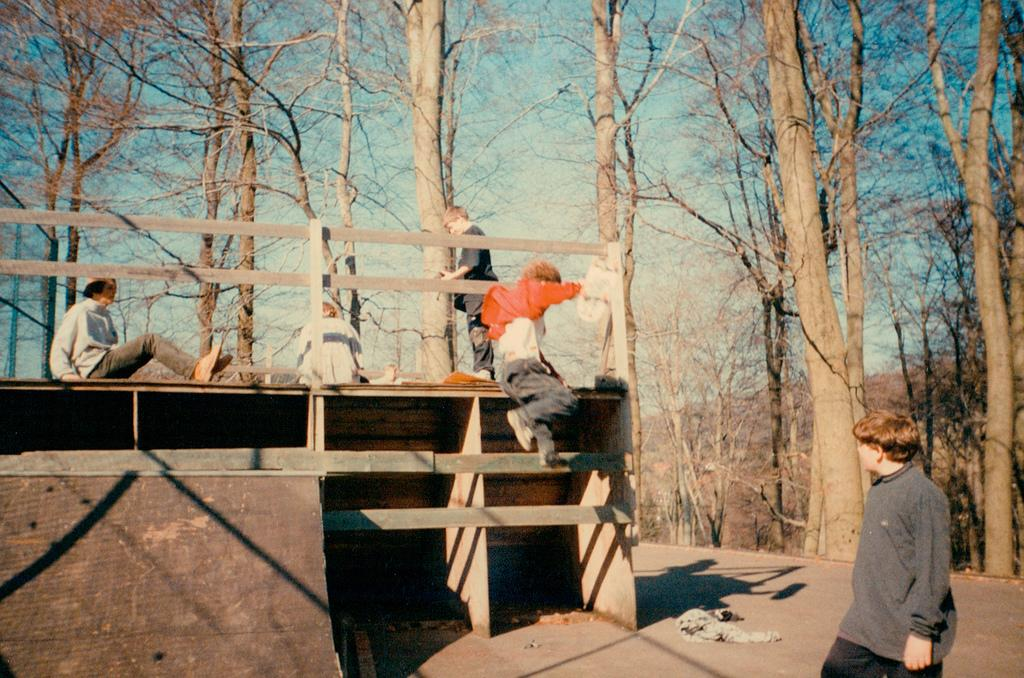What is the boy on the left side of the image doing? There is a boy sitting on a wooden frame on the left side of the image. What is the boy on the right side of the image doing? A: There is a boy walking on the right side of the image. What is the boy on the right side of the image wearing? The walking boy is wearing a coat. What type of vegetation can be seen in the image? There are big trees in the image. What type of religion is being practiced by the turkey in the image? There is no turkey present in the image, so it is not possible to determine what religion might be practiced. 